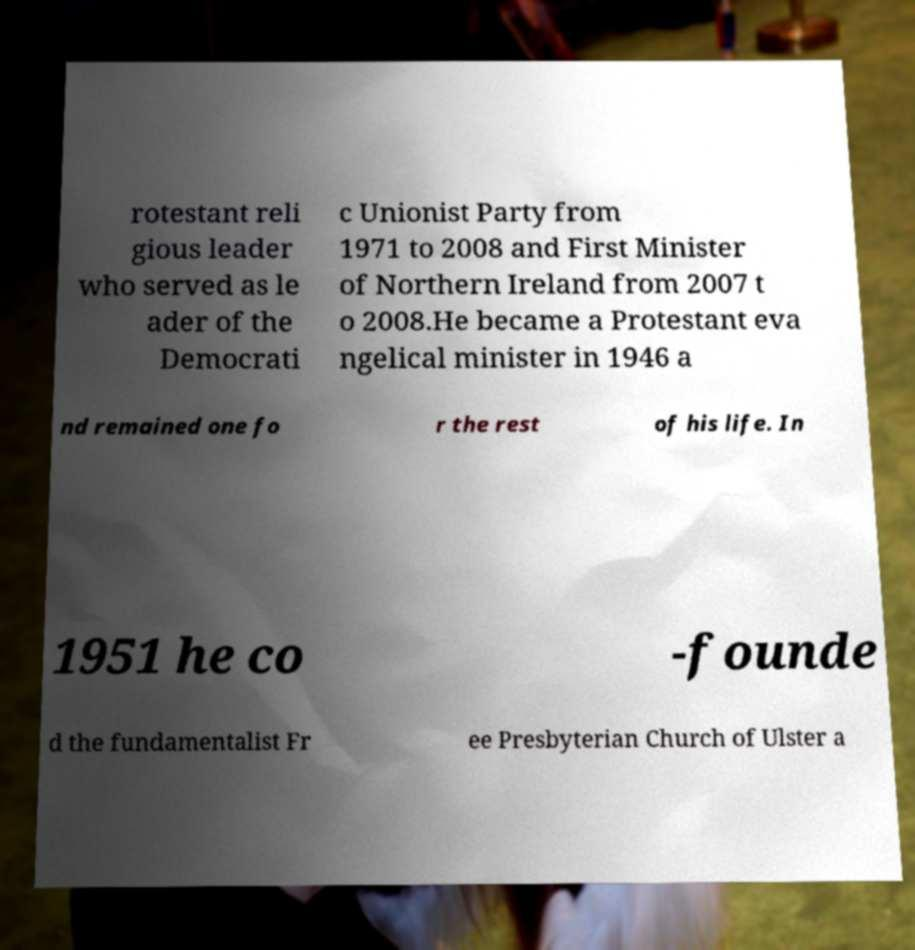For documentation purposes, I need the text within this image transcribed. Could you provide that? rotestant reli gious leader who served as le ader of the Democrati c Unionist Party from 1971 to 2008 and First Minister of Northern Ireland from 2007 t o 2008.He became a Protestant eva ngelical minister in 1946 a nd remained one fo r the rest of his life. In 1951 he co -founde d the fundamentalist Fr ee Presbyterian Church of Ulster a 